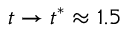Convert formula to latex. <formula><loc_0><loc_0><loc_500><loc_500>t \to t ^ { * } \approx 1 . 5</formula> 